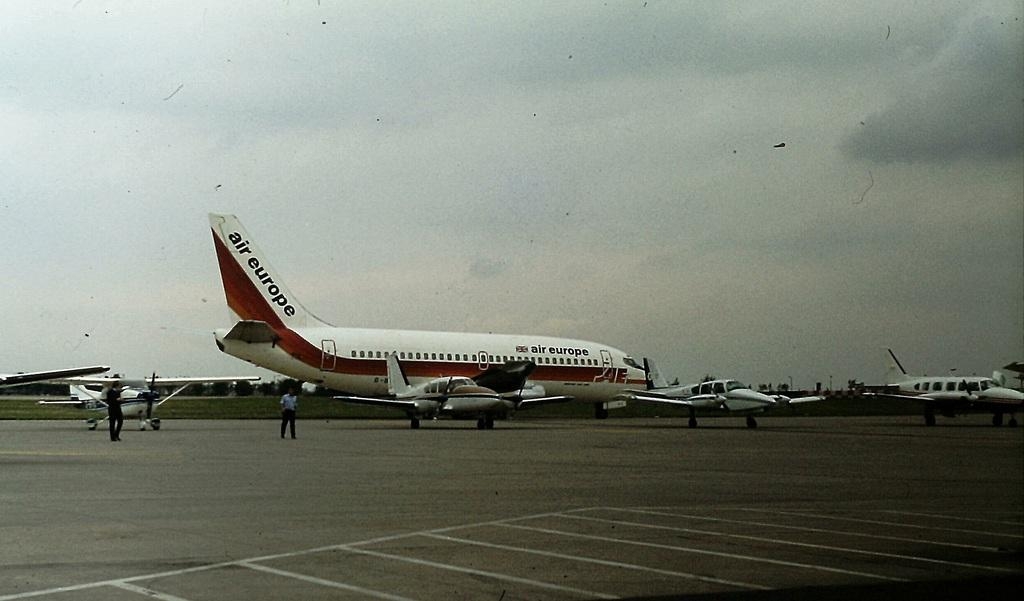<image>
Summarize the visual content of the image. A row of planes are parked on the tarmac with an Air Europe jet. 